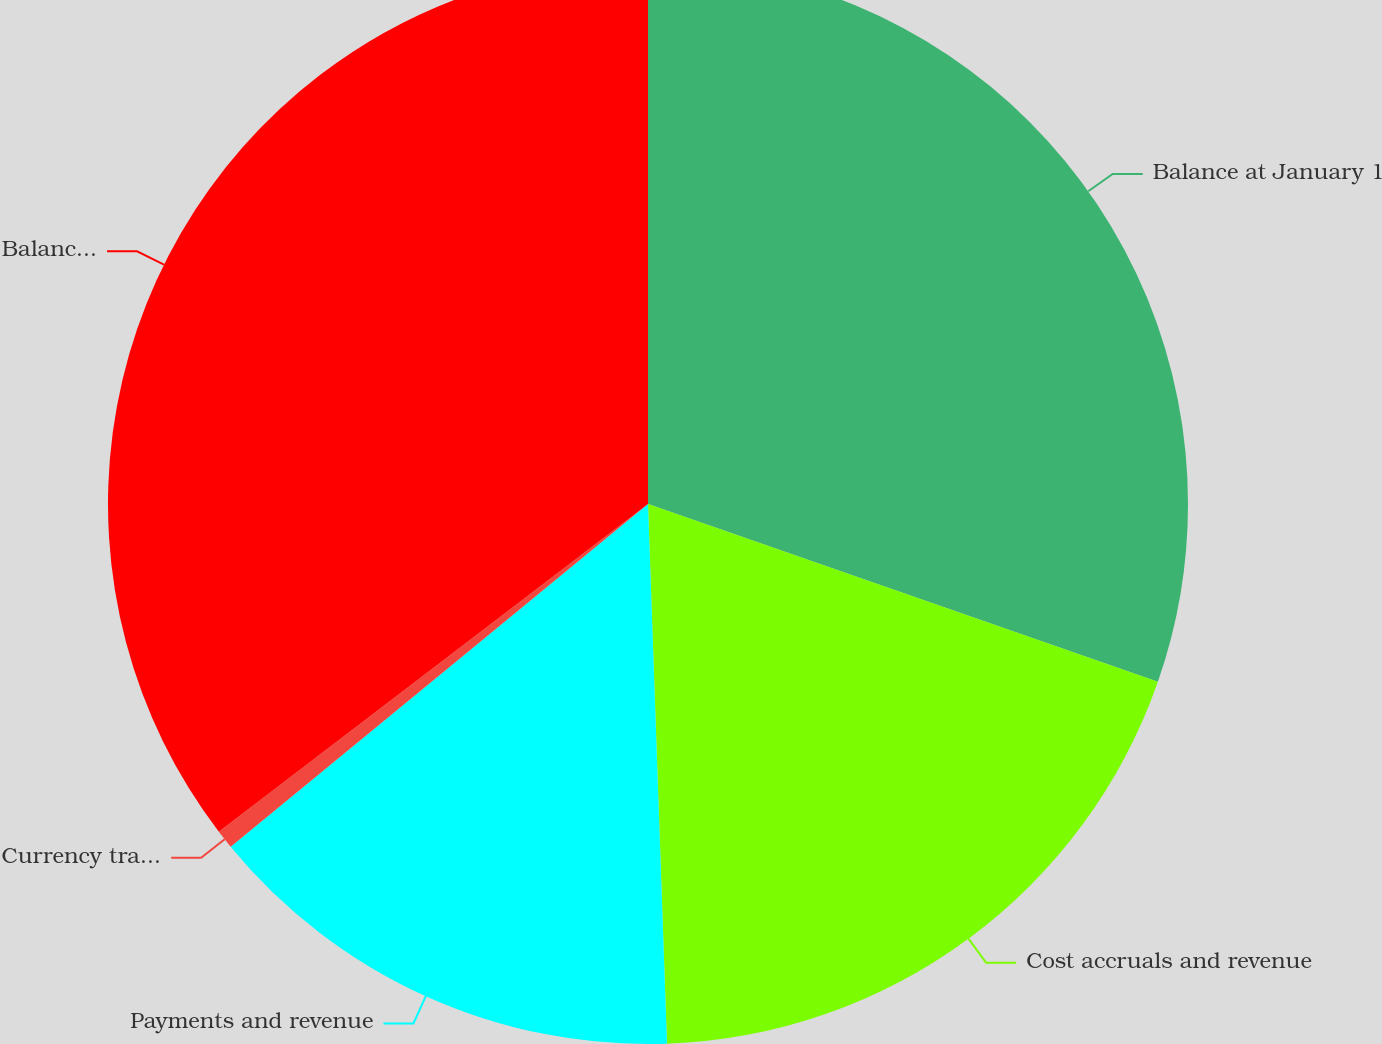Convert chart to OTSL. <chart><loc_0><loc_0><loc_500><loc_500><pie_chart><fcel>Balance at January 1<fcel>Cost accruals and revenue<fcel>Payments and revenue<fcel>Currency translation<fcel>Balance at December 31<nl><fcel>30.34%<fcel>19.1%<fcel>14.62%<fcel>0.56%<fcel>35.38%<nl></chart> 